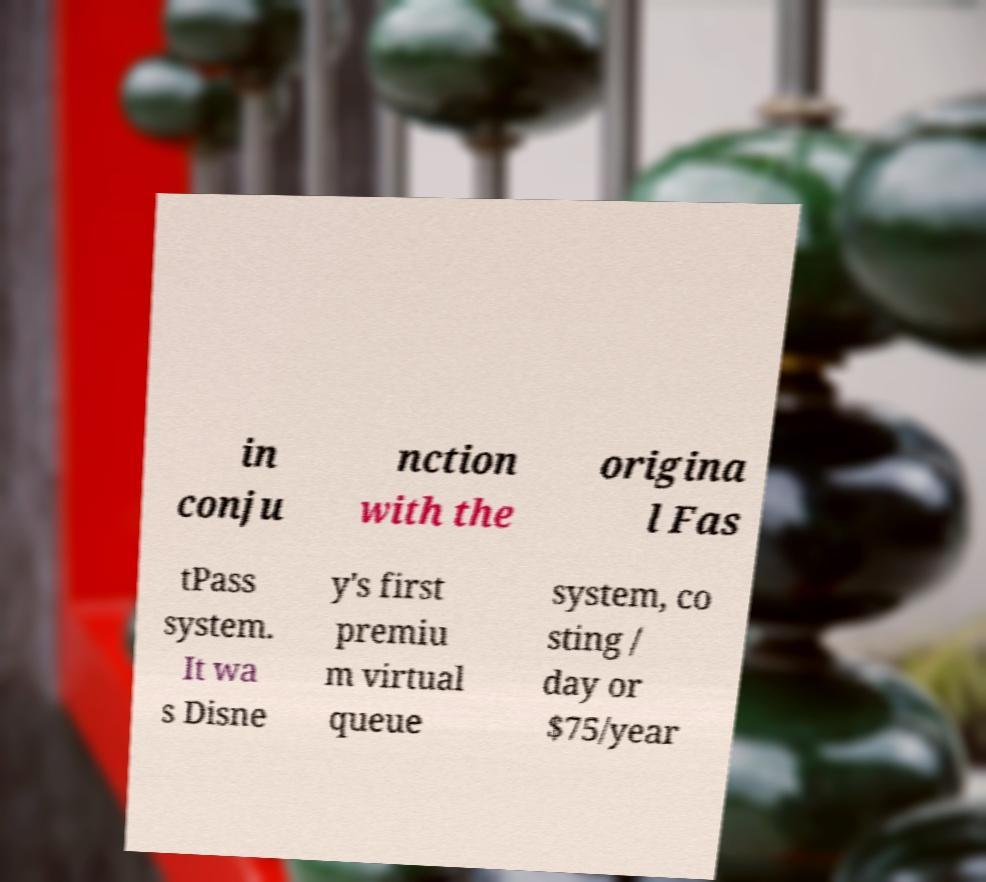There's text embedded in this image that I need extracted. Can you transcribe it verbatim? in conju nction with the origina l Fas tPass system. It wa s Disne y's first premiu m virtual queue system, co sting / day or $75/year 